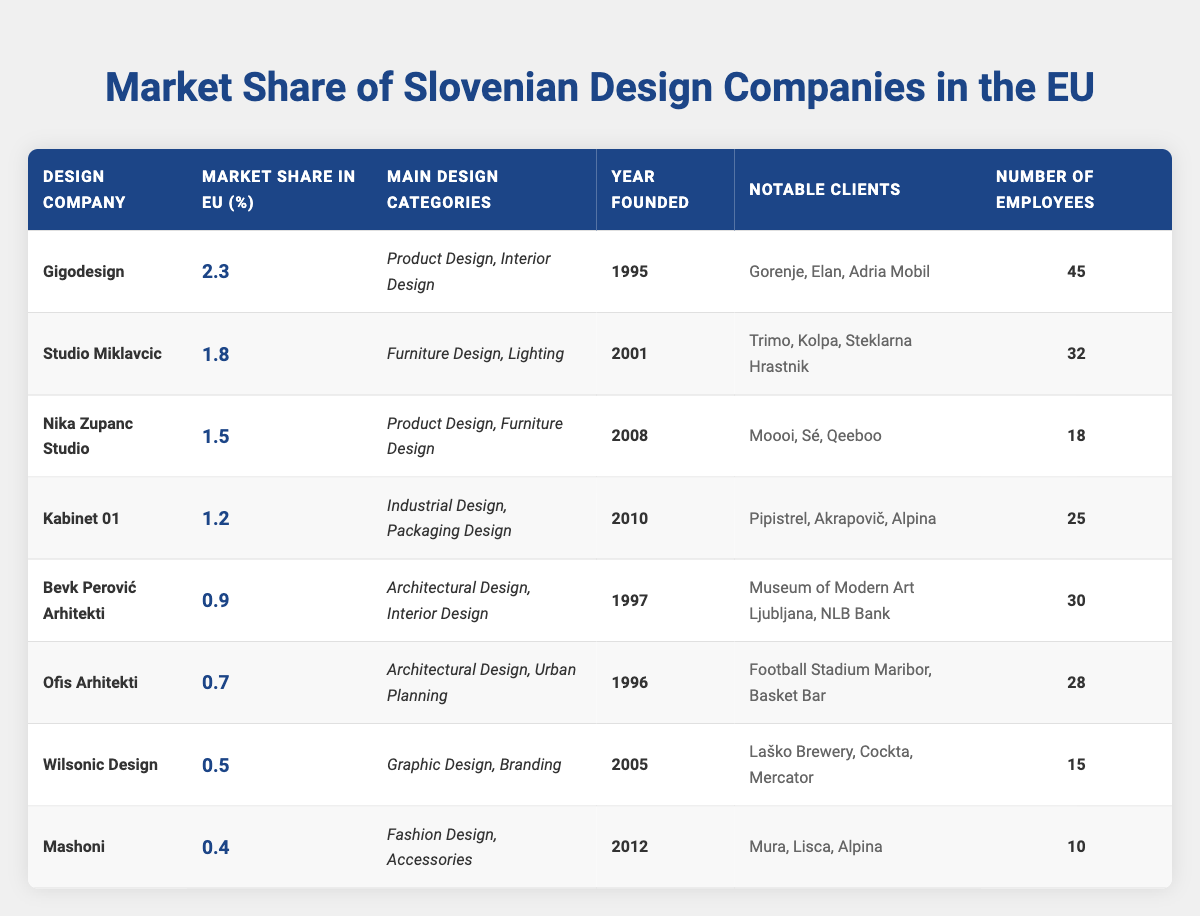What is the market share of Gigodesign in the EU? By looking at the table, the market share percentage for Gigodesign is clearly stated in the second column. It is 2.3%.
Answer: 2.3% Which design company has the highest market share? The highest market share can be found by comparing all market share percentages listed in the table. Gigodesign has the highest share at 2.3%.
Answer: Gigodesign How many employees does Studio Miklavcic have? The number of employees for Studio Miklavcic is listed in the last column of the table, which states that there are 32 employees.
Answer: 32 What is the total market share of the top three design companies? The total market share can be calculated by adding the percentages of the top three companies: Gigodesign (2.3%) + Studio Miklavcic (1.8%) + Nika Zupanc Studio (1.5%) = 5.6%.
Answer: 5.6% Is Nika Zupanc Studio older than Kabinet 01? To determine the age comparison, we can look at the "Year Founded" column. Nika Zupanc Studio was founded in 2008, while Kabinet 01 was founded in 2010, making Nika Zupanc Studio older.
Answer: Yes How many design companies have a market share below 1%? We can count how many companies have a market share percentage listed below 1%. Referring to the table, only Wilsonic Design (0.5%) and Mashoni (0.4%) fall below 1%. Thus, there are 2 companies.
Answer: 2 What categories of design does Kabinet 01 specialize in? The main design categories for Kabinet 01 are listed in the third column. They specialize in Industrial Design and Packaging Design.
Answer: Industrial Design, Packaging Design Which notable clients does Ofis Arhitekti have? The notable clients for Ofis Arhitekti can be found in the fifth column of the table, which lists Football Stadium Maribor and Basket Bar as their notable clients.
Answer: Football Stadium Maribor, Basket Bar What is the average number of employees across the listed design companies? To find the average number of employees, we add the number of employees for each company: (45 + 32 + 18 + 25 + 30 + 28 + 15 + 10) =  283. There are 8 companies, so the average is 283 / 8 = 35.375, which rounds to 35.
Answer: 35 